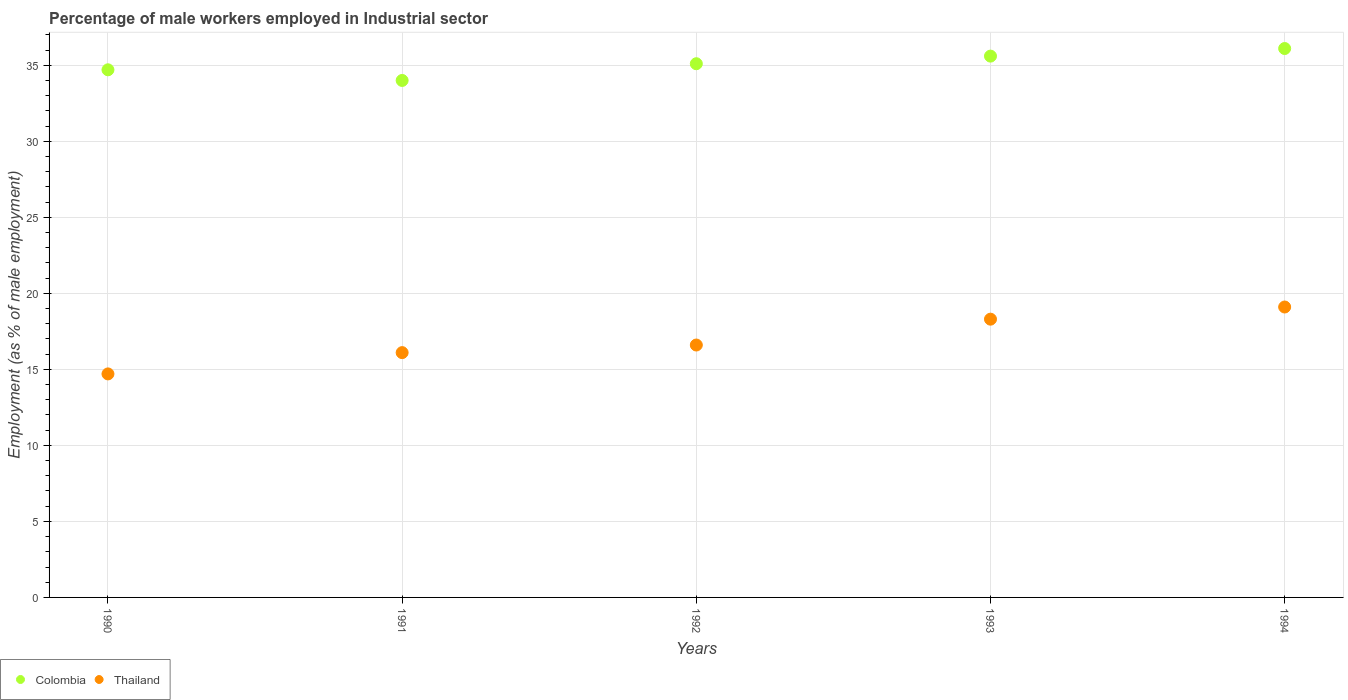How many different coloured dotlines are there?
Your answer should be compact. 2. What is the percentage of male workers employed in Industrial sector in Colombia in 1990?
Keep it short and to the point. 34.7. Across all years, what is the maximum percentage of male workers employed in Industrial sector in Colombia?
Keep it short and to the point. 36.1. Across all years, what is the minimum percentage of male workers employed in Industrial sector in Thailand?
Keep it short and to the point. 14.7. In which year was the percentage of male workers employed in Industrial sector in Thailand maximum?
Make the answer very short. 1994. In which year was the percentage of male workers employed in Industrial sector in Colombia minimum?
Your answer should be very brief. 1991. What is the total percentage of male workers employed in Industrial sector in Thailand in the graph?
Provide a short and direct response. 84.8. What is the difference between the percentage of male workers employed in Industrial sector in Colombia in 1990 and that in 1992?
Your response must be concise. -0.4. What is the difference between the percentage of male workers employed in Industrial sector in Colombia in 1992 and the percentage of male workers employed in Industrial sector in Thailand in 1994?
Offer a terse response. 16. What is the average percentage of male workers employed in Industrial sector in Colombia per year?
Make the answer very short. 35.1. In the year 1992, what is the difference between the percentage of male workers employed in Industrial sector in Thailand and percentage of male workers employed in Industrial sector in Colombia?
Make the answer very short. -18.5. What is the ratio of the percentage of male workers employed in Industrial sector in Colombia in 1993 to that in 1994?
Your answer should be very brief. 0.99. Is the difference between the percentage of male workers employed in Industrial sector in Thailand in 1991 and 1994 greater than the difference between the percentage of male workers employed in Industrial sector in Colombia in 1991 and 1994?
Your answer should be compact. No. What is the difference between the highest and the second highest percentage of male workers employed in Industrial sector in Thailand?
Make the answer very short. 0.8. What is the difference between the highest and the lowest percentage of male workers employed in Industrial sector in Colombia?
Give a very brief answer. 2.1. Does the percentage of male workers employed in Industrial sector in Colombia monotonically increase over the years?
Your response must be concise. No. Is the percentage of male workers employed in Industrial sector in Colombia strictly less than the percentage of male workers employed in Industrial sector in Thailand over the years?
Offer a very short reply. No. What is the difference between two consecutive major ticks on the Y-axis?
Keep it short and to the point. 5. Does the graph contain grids?
Give a very brief answer. Yes. What is the title of the graph?
Make the answer very short. Percentage of male workers employed in Industrial sector. What is the label or title of the X-axis?
Provide a succinct answer. Years. What is the label or title of the Y-axis?
Your response must be concise. Employment (as % of male employment). What is the Employment (as % of male employment) in Colombia in 1990?
Make the answer very short. 34.7. What is the Employment (as % of male employment) in Thailand in 1990?
Offer a terse response. 14.7. What is the Employment (as % of male employment) in Colombia in 1991?
Keep it short and to the point. 34. What is the Employment (as % of male employment) in Thailand in 1991?
Your answer should be very brief. 16.1. What is the Employment (as % of male employment) of Colombia in 1992?
Ensure brevity in your answer.  35.1. What is the Employment (as % of male employment) of Thailand in 1992?
Offer a terse response. 16.6. What is the Employment (as % of male employment) in Colombia in 1993?
Your answer should be very brief. 35.6. What is the Employment (as % of male employment) of Thailand in 1993?
Offer a terse response. 18.3. What is the Employment (as % of male employment) of Colombia in 1994?
Ensure brevity in your answer.  36.1. What is the Employment (as % of male employment) in Thailand in 1994?
Keep it short and to the point. 19.1. Across all years, what is the maximum Employment (as % of male employment) of Colombia?
Give a very brief answer. 36.1. Across all years, what is the maximum Employment (as % of male employment) of Thailand?
Keep it short and to the point. 19.1. Across all years, what is the minimum Employment (as % of male employment) of Colombia?
Your response must be concise. 34. Across all years, what is the minimum Employment (as % of male employment) of Thailand?
Give a very brief answer. 14.7. What is the total Employment (as % of male employment) of Colombia in the graph?
Give a very brief answer. 175.5. What is the total Employment (as % of male employment) in Thailand in the graph?
Keep it short and to the point. 84.8. What is the difference between the Employment (as % of male employment) of Colombia in 1990 and that in 1991?
Offer a very short reply. 0.7. What is the difference between the Employment (as % of male employment) of Colombia in 1990 and that in 1992?
Make the answer very short. -0.4. What is the difference between the Employment (as % of male employment) of Thailand in 1990 and that in 1992?
Your response must be concise. -1.9. What is the difference between the Employment (as % of male employment) in Colombia in 1990 and that in 1994?
Ensure brevity in your answer.  -1.4. What is the difference between the Employment (as % of male employment) in Thailand in 1990 and that in 1994?
Offer a very short reply. -4.4. What is the difference between the Employment (as % of male employment) of Colombia in 1991 and that in 1994?
Provide a short and direct response. -2.1. What is the difference between the Employment (as % of male employment) in Thailand in 1991 and that in 1994?
Provide a short and direct response. -3. What is the difference between the Employment (as % of male employment) in Colombia in 1992 and that in 1993?
Provide a succinct answer. -0.5. What is the difference between the Employment (as % of male employment) in Colombia in 1992 and that in 1994?
Your answer should be compact. -1. What is the difference between the Employment (as % of male employment) in Thailand in 1992 and that in 1994?
Keep it short and to the point. -2.5. What is the difference between the Employment (as % of male employment) in Colombia in 1990 and the Employment (as % of male employment) in Thailand in 1991?
Keep it short and to the point. 18.6. What is the difference between the Employment (as % of male employment) of Colombia in 1990 and the Employment (as % of male employment) of Thailand in 1993?
Offer a very short reply. 16.4. What is the difference between the Employment (as % of male employment) in Colombia in 1990 and the Employment (as % of male employment) in Thailand in 1994?
Ensure brevity in your answer.  15.6. What is the average Employment (as % of male employment) in Colombia per year?
Offer a very short reply. 35.1. What is the average Employment (as % of male employment) of Thailand per year?
Offer a terse response. 16.96. In the year 1992, what is the difference between the Employment (as % of male employment) of Colombia and Employment (as % of male employment) of Thailand?
Ensure brevity in your answer.  18.5. What is the ratio of the Employment (as % of male employment) in Colombia in 1990 to that in 1991?
Keep it short and to the point. 1.02. What is the ratio of the Employment (as % of male employment) in Thailand in 1990 to that in 1992?
Your answer should be very brief. 0.89. What is the ratio of the Employment (as % of male employment) of Colombia in 1990 to that in 1993?
Provide a succinct answer. 0.97. What is the ratio of the Employment (as % of male employment) of Thailand in 1990 to that in 1993?
Your answer should be very brief. 0.8. What is the ratio of the Employment (as % of male employment) in Colombia in 1990 to that in 1994?
Give a very brief answer. 0.96. What is the ratio of the Employment (as % of male employment) in Thailand in 1990 to that in 1994?
Give a very brief answer. 0.77. What is the ratio of the Employment (as % of male employment) of Colombia in 1991 to that in 1992?
Make the answer very short. 0.97. What is the ratio of the Employment (as % of male employment) in Thailand in 1991 to that in 1992?
Ensure brevity in your answer.  0.97. What is the ratio of the Employment (as % of male employment) in Colombia in 1991 to that in 1993?
Your response must be concise. 0.96. What is the ratio of the Employment (as % of male employment) of Thailand in 1991 to that in 1993?
Offer a very short reply. 0.88. What is the ratio of the Employment (as % of male employment) of Colombia in 1991 to that in 1994?
Offer a terse response. 0.94. What is the ratio of the Employment (as % of male employment) of Thailand in 1991 to that in 1994?
Offer a very short reply. 0.84. What is the ratio of the Employment (as % of male employment) in Colombia in 1992 to that in 1993?
Give a very brief answer. 0.99. What is the ratio of the Employment (as % of male employment) of Thailand in 1992 to that in 1993?
Your answer should be very brief. 0.91. What is the ratio of the Employment (as % of male employment) of Colombia in 1992 to that in 1994?
Keep it short and to the point. 0.97. What is the ratio of the Employment (as % of male employment) in Thailand in 1992 to that in 1994?
Your answer should be compact. 0.87. What is the ratio of the Employment (as % of male employment) of Colombia in 1993 to that in 1994?
Make the answer very short. 0.99. What is the ratio of the Employment (as % of male employment) in Thailand in 1993 to that in 1994?
Your answer should be compact. 0.96. What is the difference between the highest and the second highest Employment (as % of male employment) in Colombia?
Keep it short and to the point. 0.5. What is the difference between the highest and the second highest Employment (as % of male employment) of Thailand?
Provide a short and direct response. 0.8. What is the difference between the highest and the lowest Employment (as % of male employment) of Colombia?
Provide a succinct answer. 2.1. What is the difference between the highest and the lowest Employment (as % of male employment) of Thailand?
Provide a short and direct response. 4.4. 